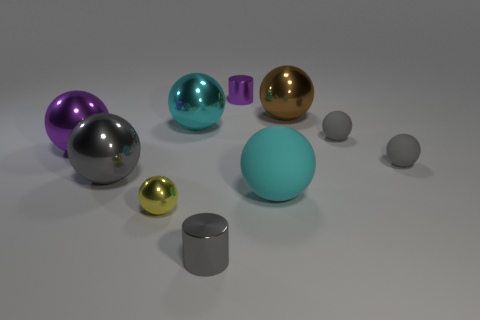Subtract all cyan cylinders. How many gray balls are left? 3 Subtract all large cyan rubber balls. How many balls are left? 7 Subtract all brown balls. How many balls are left? 7 Subtract all red balls. Subtract all green cubes. How many balls are left? 8 Subtract all balls. How many objects are left? 2 Add 3 big brown shiny objects. How many big brown shiny objects are left? 4 Add 2 purple metallic cylinders. How many purple metallic cylinders exist? 3 Subtract 0 blue spheres. How many objects are left? 10 Subtract all purple spheres. Subtract all purple shiny cylinders. How many objects are left? 8 